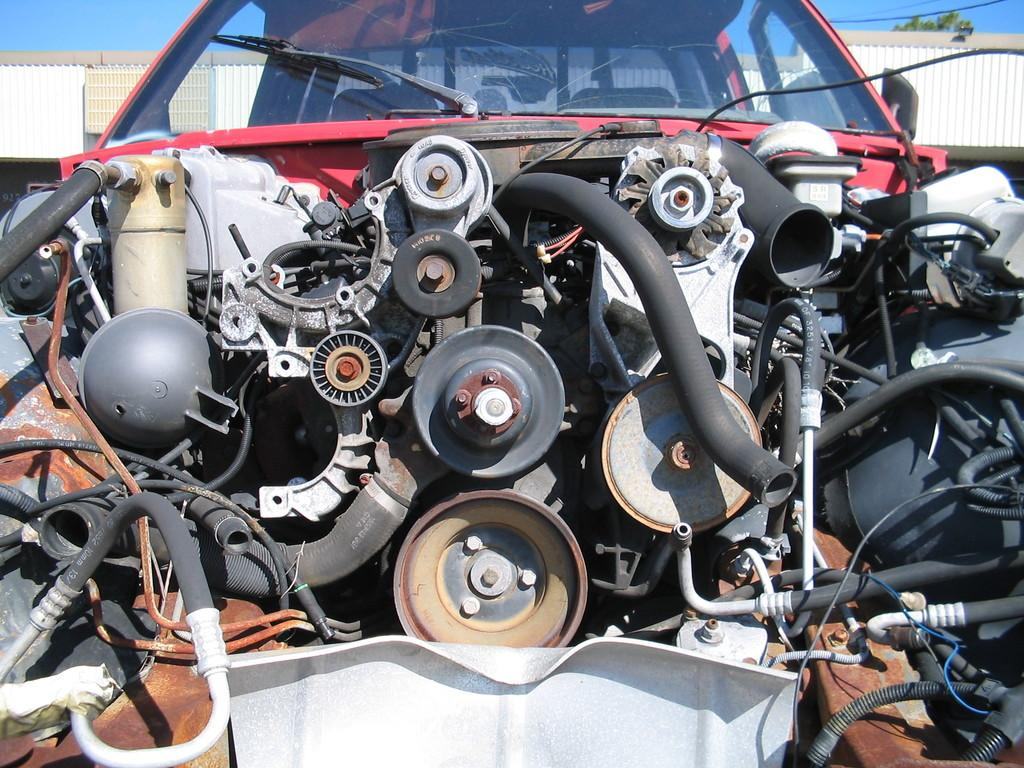What is the main subject of the image? The main subject of the image is a vehicle without a bonnet. What can be seen in the background of the image? There is a building in the background of the image. What type of vegetation is visible in the image? There are leaves of a tree visible in the image. What is visible above the vehicle and building? The sky is visible in the image. How many cables are connected to the vehicle in the image? There are no cables connected to the vehicle in the image. What type of snails can be seen crawling on the leaves in the image? There are no snails present in the image; only leaves of a tree are visible. 